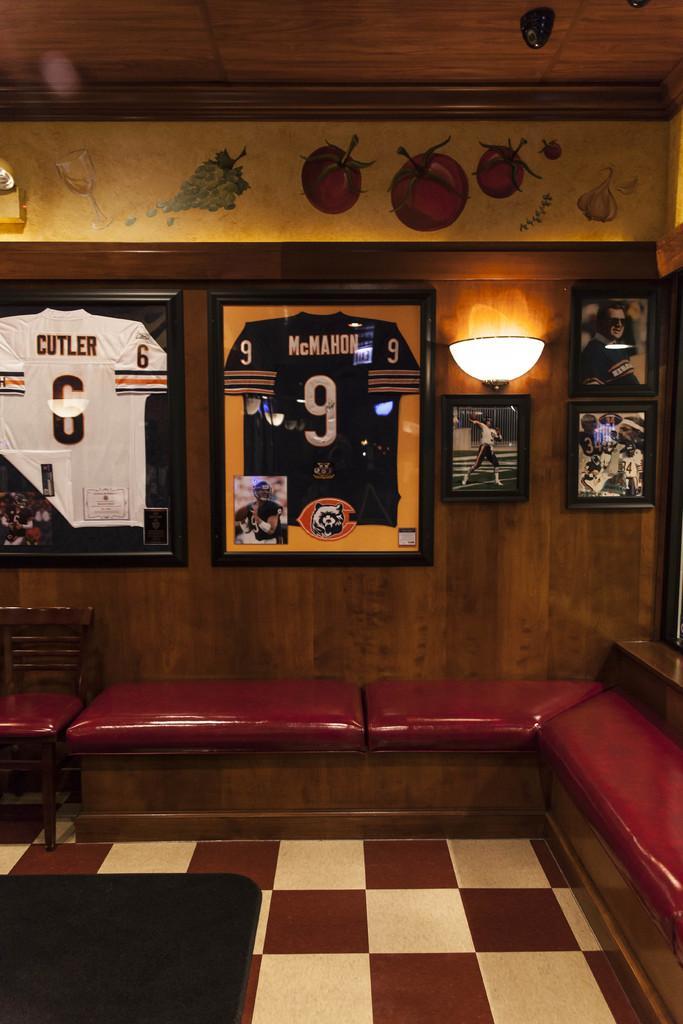Could you give a brief overview of what you see in this image? In this image I see a room in which there is a floor, a chair and few sofas. In the background I see 2 frames of t-shirts and 3 photo frames, a light and few vegetables art and a glass art. 